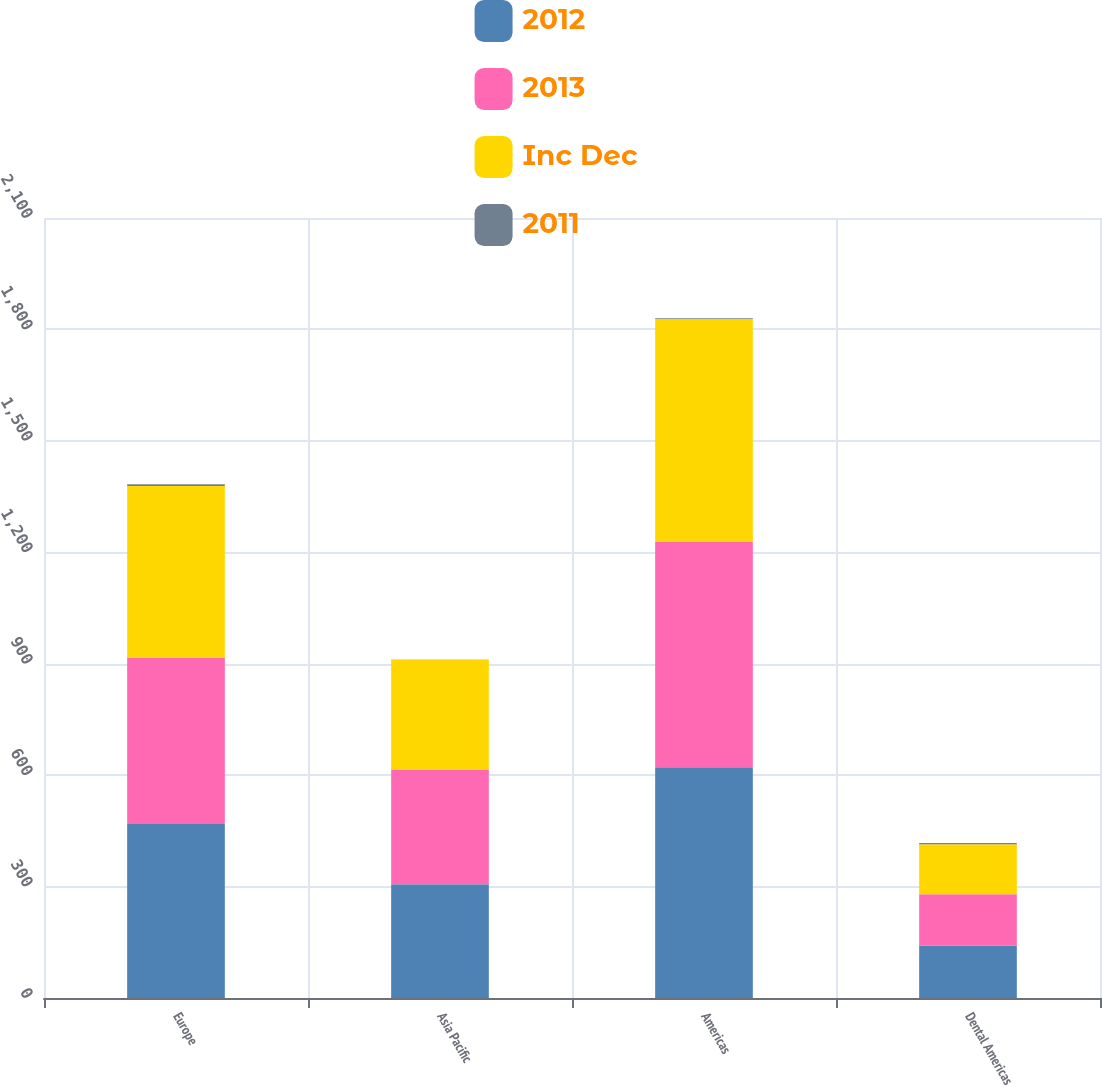Convert chart. <chart><loc_0><loc_0><loc_500><loc_500><stacked_bar_chart><ecel><fcel>Europe<fcel>Asia Pacific<fcel>Americas<fcel>Dental Americas<nl><fcel>2012<fcel>468.3<fcel>306.3<fcel>621<fcel>141.6<nl><fcel>2013<fcel>447.3<fcel>308.6<fcel>606.7<fcel>137.8<nl><fcel>Inc Dec<fcel>462.6<fcel>295<fcel>600.7<fcel>134.7<nl><fcel>2011<fcel>5<fcel>1<fcel>2<fcel>3<nl></chart> 